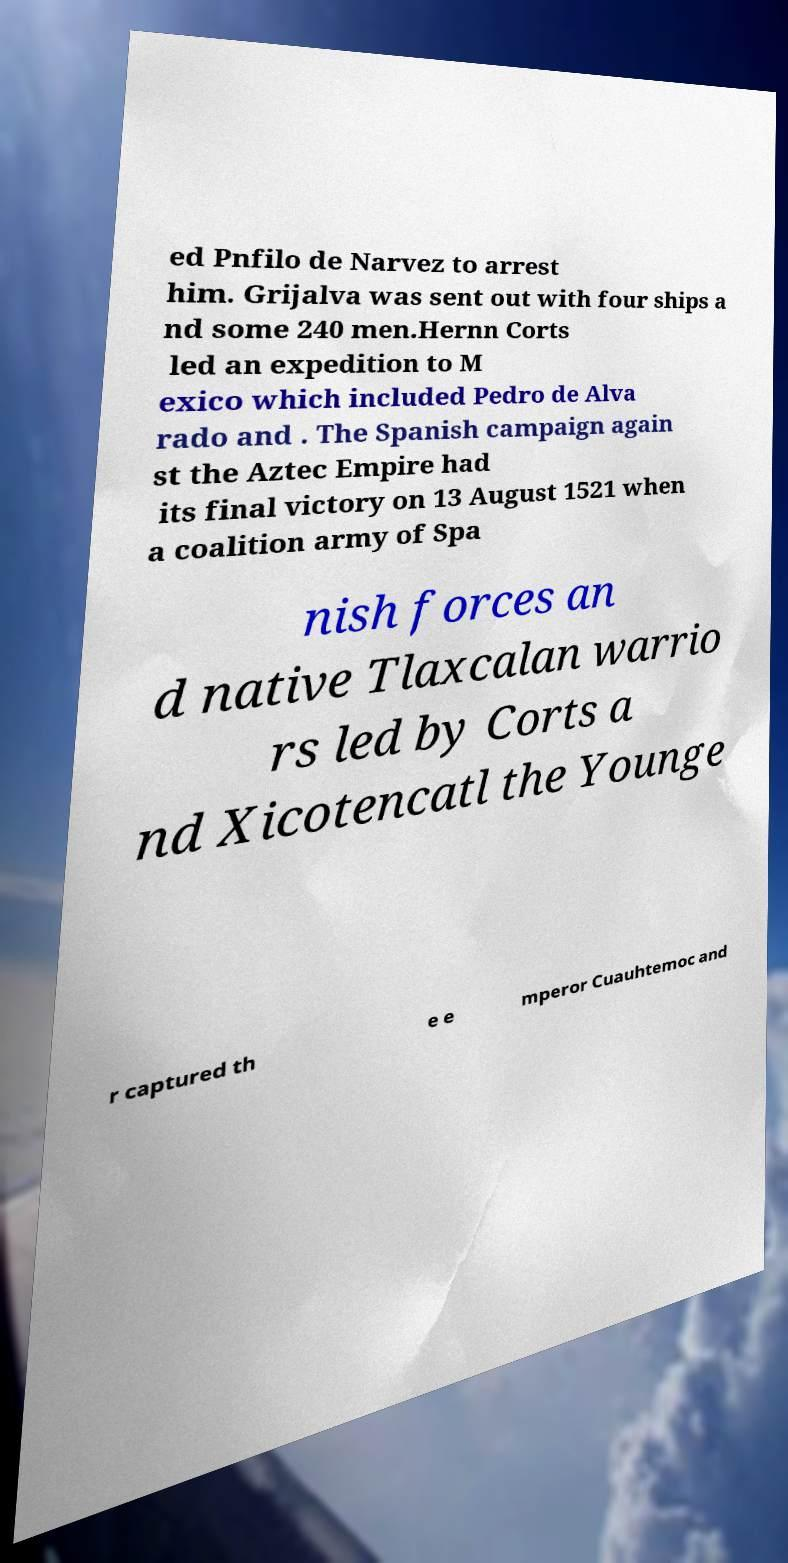Could you extract and type out the text from this image? ed Pnfilo de Narvez to arrest him. Grijalva was sent out with four ships a nd some 240 men.Hernn Corts led an expedition to M exico which included Pedro de Alva rado and . The Spanish campaign again st the Aztec Empire had its final victory on 13 August 1521 when a coalition army of Spa nish forces an d native Tlaxcalan warrio rs led by Corts a nd Xicotencatl the Younge r captured th e e mperor Cuauhtemoc and 